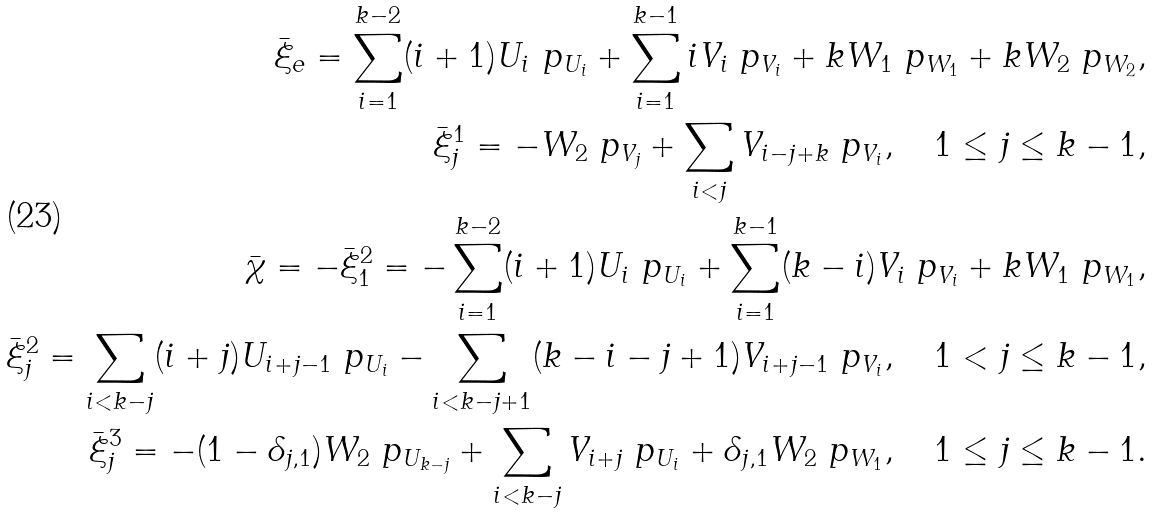Convert formula to latex. <formula><loc_0><loc_0><loc_500><loc_500>\bar { \xi } _ { e } = \sum _ { i = 1 } ^ { k - 2 } ( i + 1 ) U _ { i } \ p _ { U _ { i } } + \sum _ { i = 1 } ^ { k - 1 } i V _ { i } \ p _ { V _ { i } } + k W _ { 1 } \ p _ { W _ { 1 } } + k W _ { 2 } \ p _ { W _ { 2 } } , \\ \bar { \xi } _ { j } ^ { 1 } = - W _ { 2 } \ p _ { V _ { j } } + \sum _ { i < j } V _ { i - j + k } \ p _ { V _ { i } } , \quad 1 \leq j \leq k - 1 , \\ \bar { \chi } = - \bar { \xi } ^ { 2 } _ { 1 } = - \sum _ { i = 1 } ^ { k - 2 } ( i + 1 ) U _ { i } \ p _ { U _ { i } } + \sum _ { i = 1 } ^ { k - 1 } ( k - i ) V _ { i } \ p _ { V _ { i } } + k W _ { 1 } \ p _ { W _ { 1 } } , \\ \bar { \xi } _ { j } ^ { 2 } = \sum _ { i < k - j } ( i + j ) U _ { i + j - 1 } \ p _ { U _ { i } } - \sum _ { i < k - j + 1 } ( k - i - j + 1 ) V _ { i + j - 1 } \ p _ { V _ { i } } , \quad 1 < j \leq k - 1 , \\ \bar { \xi } ^ { 3 } _ { j } = - ( 1 - \delta _ { j , 1 } ) W _ { 2 } \ p _ { U _ { k - j } } + \sum _ { i < k - j } V _ { i + j } \ p _ { U _ { i } } + \delta _ { j , 1 } W _ { 2 } \ p _ { W _ { 1 } } , \quad 1 \leq j \leq k - 1 .</formula> 